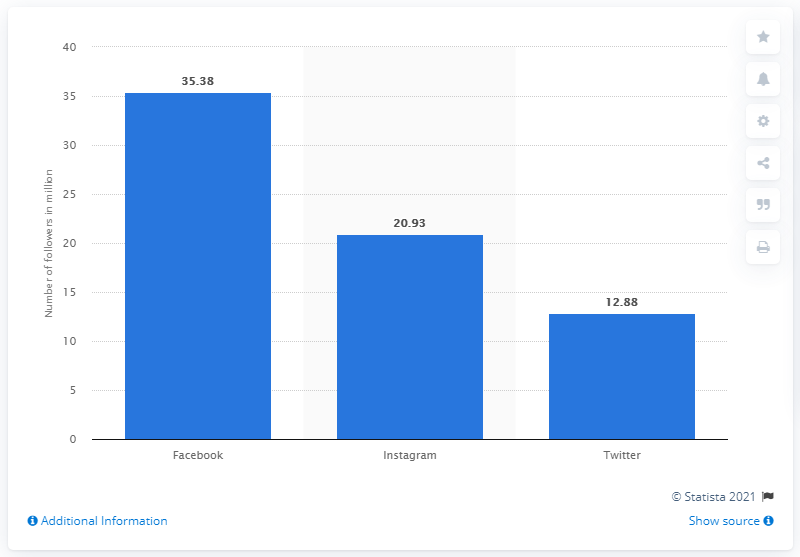Mention a couple of crucial points in this snapshot. In November 2019, Liverpool had 35,380 Facebook fans. 